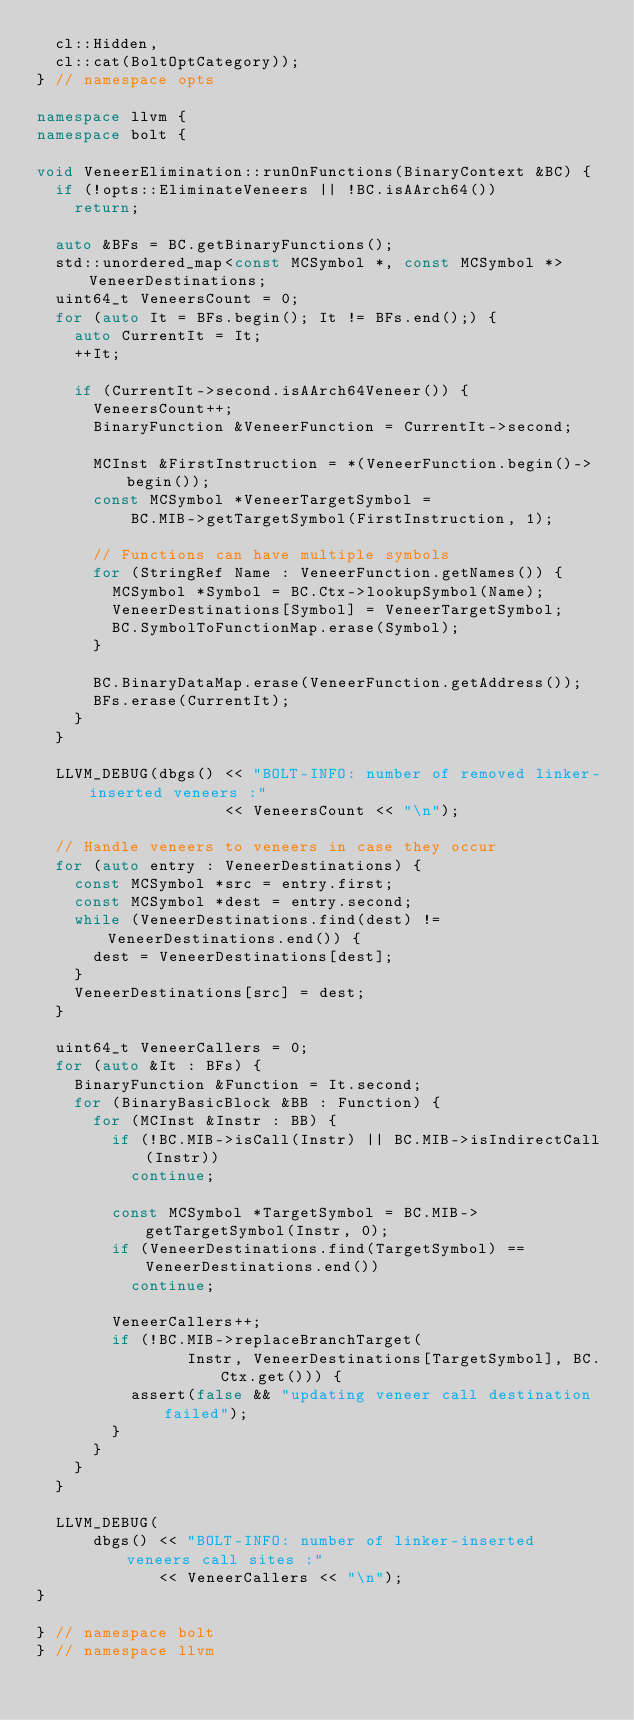Convert code to text. <code><loc_0><loc_0><loc_500><loc_500><_C++_>  cl::Hidden,
  cl::cat(BoltOptCategory));
} // namespace opts

namespace llvm {
namespace bolt {

void VeneerElimination::runOnFunctions(BinaryContext &BC) {
  if (!opts::EliminateVeneers || !BC.isAArch64())
    return;

  auto &BFs = BC.getBinaryFunctions();
  std::unordered_map<const MCSymbol *, const MCSymbol *> VeneerDestinations;
  uint64_t VeneersCount = 0;
  for (auto It = BFs.begin(); It != BFs.end();) {
    auto CurrentIt = It;
    ++It;

    if (CurrentIt->second.isAArch64Veneer()) {
      VeneersCount++;
      BinaryFunction &VeneerFunction = CurrentIt->second;

      MCInst &FirstInstruction = *(VeneerFunction.begin()->begin());
      const MCSymbol *VeneerTargetSymbol =
          BC.MIB->getTargetSymbol(FirstInstruction, 1);

      // Functions can have multiple symbols
      for (StringRef Name : VeneerFunction.getNames()) {
        MCSymbol *Symbol = BC.Ctx->lookupSymbol(Name);
        VeneerDestinations[Symbol] = VeneerTargetSymbol;
        BC.SymbolToFunctionMap.erase(Symbol);
      }

      BC.BinaryDataMap.erase(VeneerFunction.getAddress());
      BFs.erase(CurrentIt);
    }
  }

  LLVM_DEBUG(dbgs() << "BOLT-INFO: number of removed linker-inserted veneers :"
                    << VeneersCount << "\n");

  // Handle veneers to veneers in case they occur
  for (auto entry : VeneerDestinations) {
    const MCSymbol *src = entry.first;
    const MCSymbol *dest = entry.second;
    while (VeneerDestinations.find(dest) != VeneerDestinations.end()) {
      dest = VeneerDestinations[dest];
    }
    VeneerDestinations[src] = dest;
  }

  uint64_t VeneerCallers = 0;
  for (auto &It : BFs) {
    BinaryFunction &Function = It.second;
    for (BinaryBasicBlock &BB : Function) {
      for (MCInst &Instr : BB) {
        if (!BC.MIB->isCall(Instr) || BC.MIB->isIndirectCall(Instr))
          continue;

        const MCSymbol *TargetSymbol = BC.MIB->getTargetSymbol(Instr, 0);
        if (VeneerDestinations.find(TargetSymbol) == VeneerDestinations.end())
          continue;

        VeneerCallers++;
        if (!BC.MIB->replaceBranchTarget(
                Instr, VeneerDestinations[TargetSymbol], BC.Ctx.get())) {
          assert(false && "updating veneer call destination failed");
        }
      }
    }
  }

  LLVM_DEBUG(
      dbgs() << "BOLT-INFO: number of linker-inserted veneers call sites :"
             << VeneerCallers << "\n");
}

} // namespace bolt
} // namespace llvm
</code> 